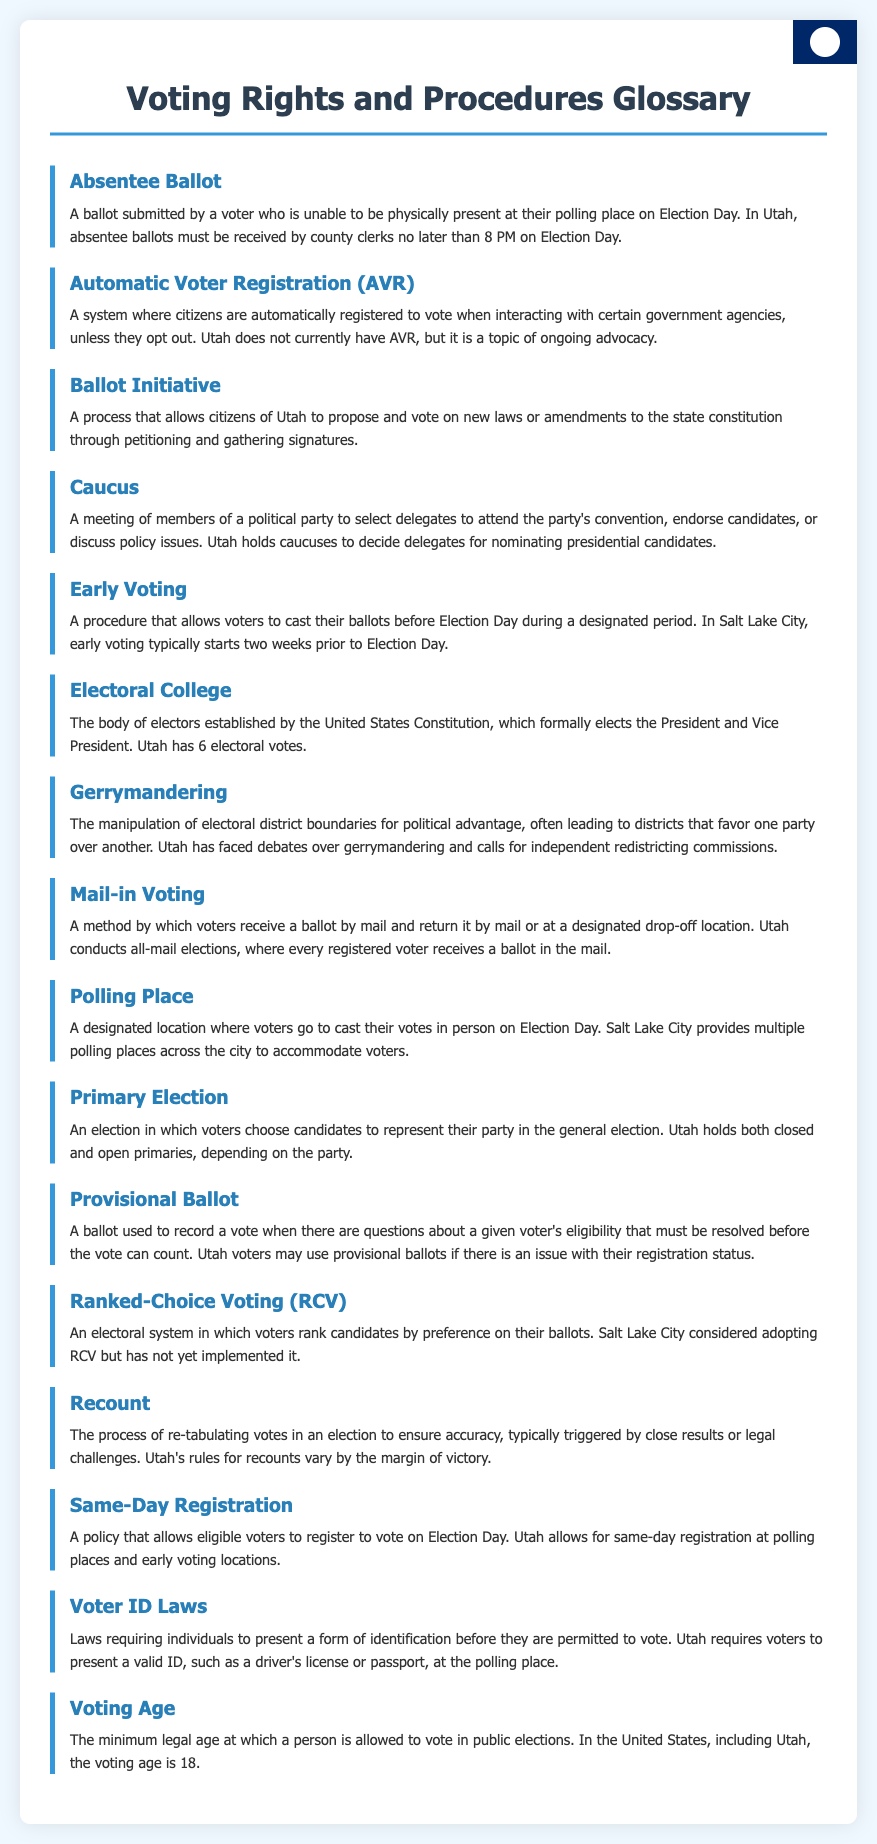what is an absentee ballot? An absentee ballot is a ballot submitted by a voter who is unable to be physically present at their polling place on Election Day.
Answer: A ballot submitted by a voter who is unable to be physically present how many electoral votes does Utah have? The document states that Utah has 6 electoral votes.
Answer: 6 what is the primary election process in Utah? The primary election in Utah is where voters choose candidates to represent their party in the general election.
Answer: Voters choose candidates to represent their party what does gerrymandering refer to? Gerrymandering refers to the manipulation of electoral district boundaries for political advantage.
Answer: Manipulation of electoral district boundaries for political advantage which voting method does Utah use for elections? The document states that Utah conducts all-mail elections, where every registered voter receives a ballot in the mail.
Answer: All-mail elections what allows Utah voters to register on Election Day? Same-Day Registration is the policy that allows eligible voters to register on Election Day.
Answer: Same-Day Registration what is the minimum voting age in the United States? The voting age is defined as the minimum legal age at which a person is allowed to vote, which is 18.
Answer: 18 how are votes recounted in Utah? A recount is the process of re-tabulating votes in an election to ensure accuracy, triggered typically by close results.
Answer: Re-tabulating votes to ensure accuracy what is the definition of ranked-choice voting? Ranked-choice voting is an electoral system in which voters rank candidates by preference on their ballots.
Answer: An electoral system where voters rank candidates by preference 